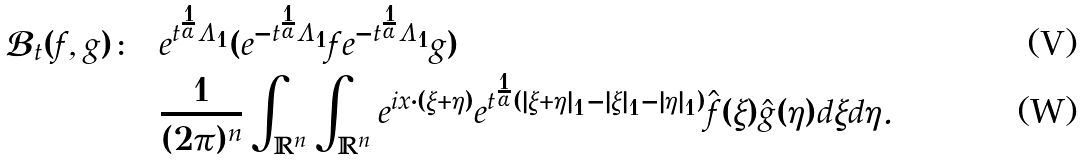<formula> <loc_0><loc_0><loc_500><loc_500>\mathcal { B } _ { t } ( f , g ) \colon & = e ^ { t ^ { \frac { 1 } { \alpha } } \Lambda _ { 1 } } ( e ^ { - t ^ { \frac { 1 } { \alpha } } \Lambda _ { 1 } } f e ^ { - t ^ { \frac { 1 } { \alpha } } \Lambda _ { 1 } } g ) \\ & = \frac { 1 } { ( 2 \pi ) ^ { n } } \int _ { \mathbb { R } ^ { n } } \int _ { \mathbb { R } ^ { n } } e ^ { i x \cdot ( \xi + \eta ) } e ^ { t ^ { \frac { 1 } { \alpha } } ( | \xi + \eta | _ { 1 } - | \xi | _ { 1 } - | \eta | _ { 1 } ) } \hat { f } ( \xi ) \hat { g } ( \eta ) d \xi d \eta .</formula> 